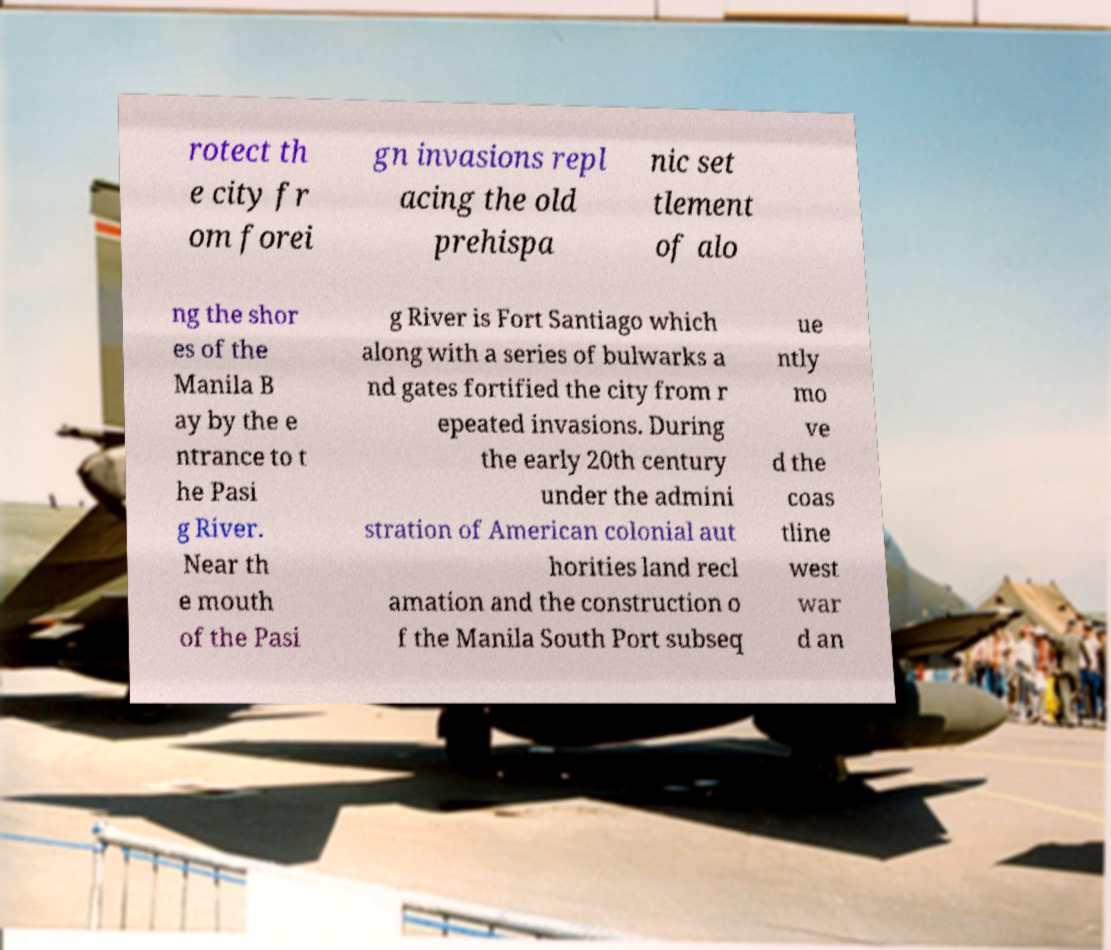For documentation purposes, I need the text within this image transcribed. Could you provide that? rotect th e city fr om forei gn invasions repl acing the old prehispa nic set tlement of alo ng the shor es of the Manila B ay by the e ntrance to t he Pasi g River. Near th e mouth of the Pasi g River is Fort Santiago which along with a series of bulwarks a nd gates fortified the city from r epeated invasions. During the early 20th century under the admini stration of American colonial aut horities land recl amation and the construction o f the Manila South Port subseq ue ntly mo ve d the coas tline west war d an 